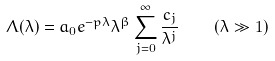Convert formula to latex. <formula><loc_0><loc_0><loc_500><loc_500>\Lambda ( \lambda ) = a _ { 0 } e ^ { - p \lambda } \lambda ^ { \beta } \sum ^ { \infty } _ { j = 0 } \frac { c _ { j } } { \lambda ^ { j } } \quad ( \lambda \gg 1 )</formula> 